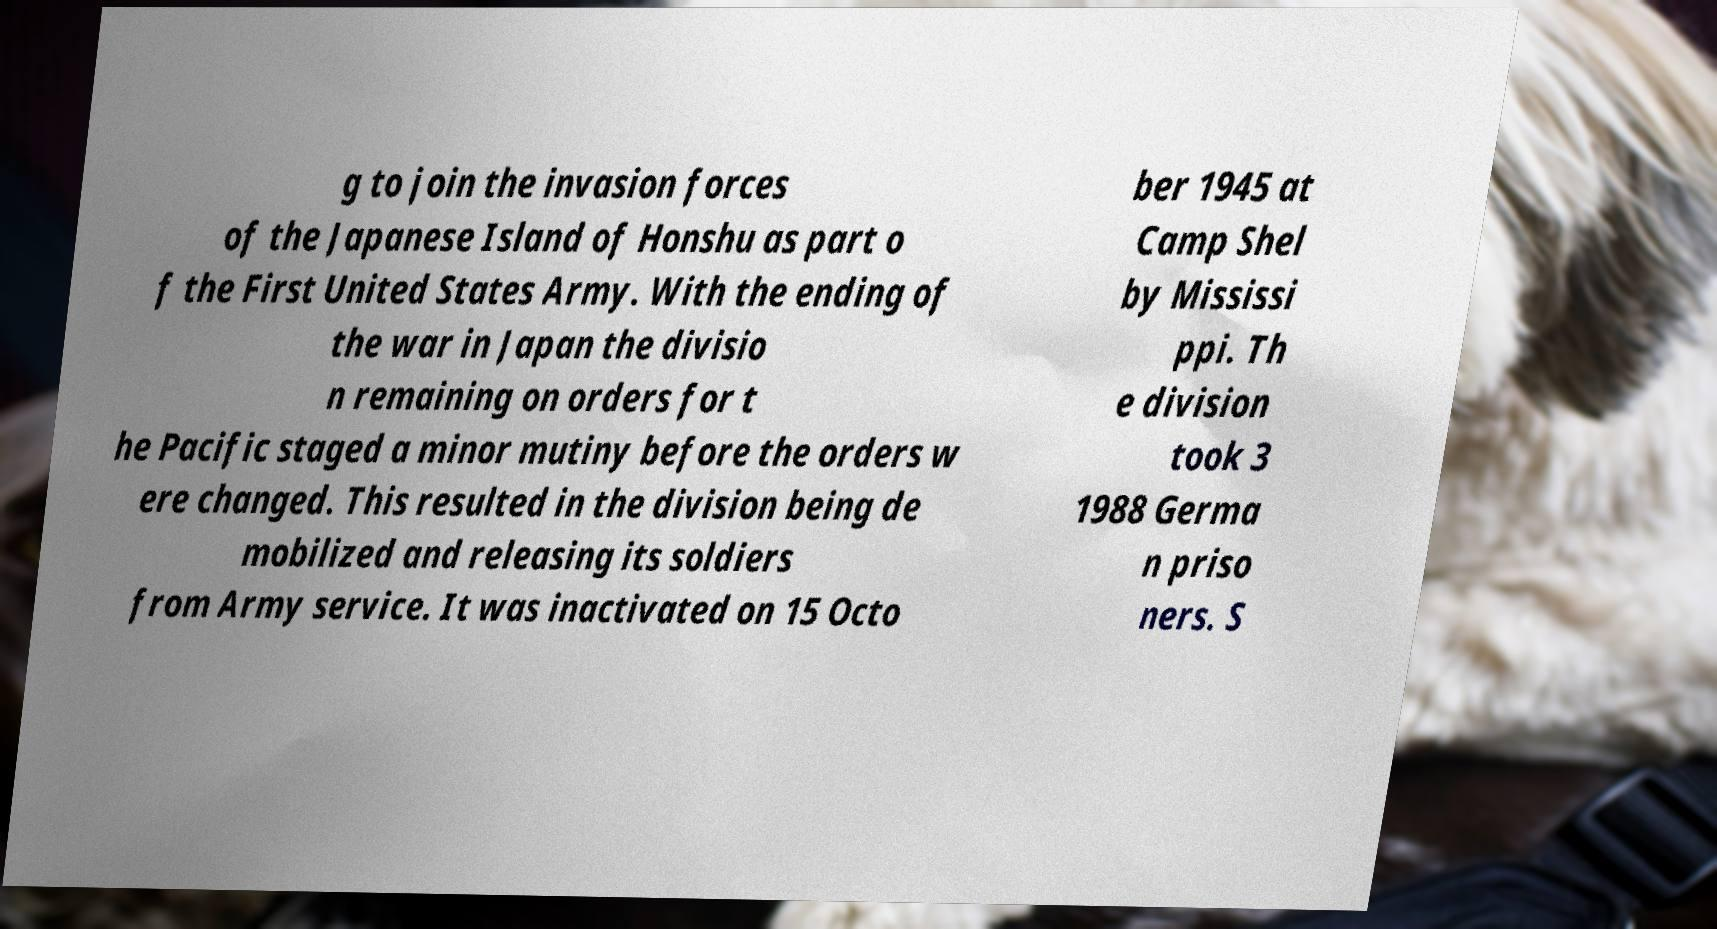Could you extract and type out the text from this image? g to join the invasion forces of the Japanese Island of Honshu as part o f the First United States Army. With the ending of the war in Japan the divisio n remaining on orders for t he Pacific staged a minor mutiny before the orders w ere changed. This resulted in the division being de mobilized and releasing its soldiers from Army service. It was inactivated on 15 Octo ber 1945 at Camp Shel by Mississi ppi. Th e division took 3 1988 Germa n priso ners. S 